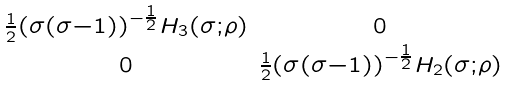Convert formula to latex. <formula><loc_0><loc_0><loc_500><loc_500>\begin{smallmatrix} \frac { 1 } { 2 } \left ( \sigma ( \sigma - 1 ) \right ) ^ { - \frac { 1 } { 2 } } H _ { 3 } ( \sigma ; \rho ) & 0 \\ 0 & \frac { 1 } { 2 } \left ( \sigma ( \sigma - 1 ) \right ) ^ { - \frac { 1 } { 2 } } H _ { 2 } ( \sigma ; \rho ) \end{smallmatrix}</formula> 